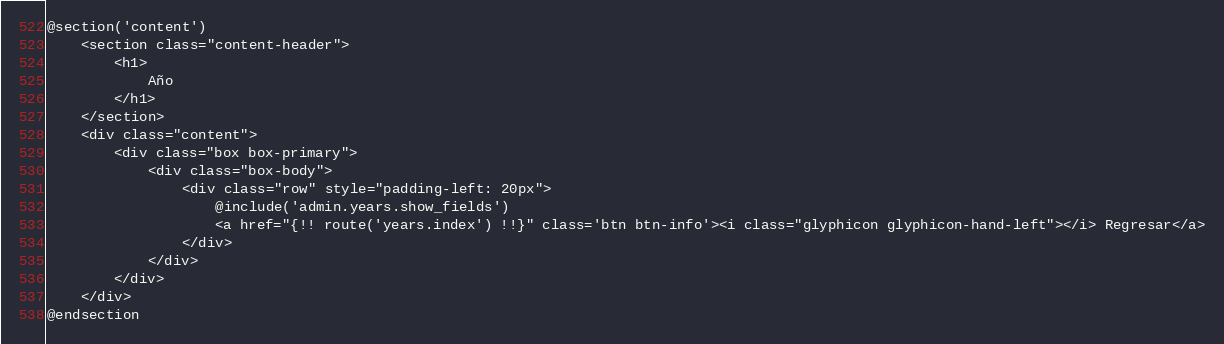Convert code to text. <code><loc_0><loc_0><loc_500><loc_500><_PHP_>@section('content')
    <section class="content-header">
        <h1>
            Año
        </h1>
    </section>
    <div class="content">
        <div class="box box-primary">
            <div class="box-body">
                <div class="row" style="padding-left: 20px">
                    @include('admin.years.show_fields')
                    <a href="{!! route('years.index') !!}" class='btn btn-info'><i class="glyphicon glyphicon-hand-left"></i> Regresar</a>
                </div>
            </div>
        </div>
    </div>
@endsection
</code> 